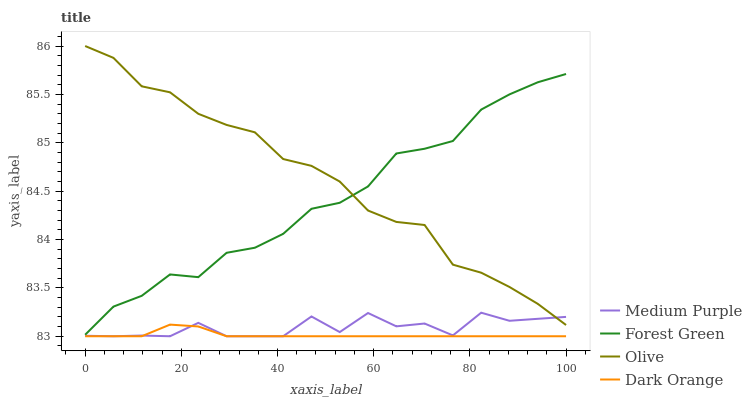Does Dark Orange have the minimum area under the curve?
Answer yes or no. Yes. Does Olive have the maximum area under the curve?
Answer yes or no. Yes. Does Forest Green have the minimum area under the curve?
Answer yes or no. No. Does Forest Green have the maximum area under the curve?
Answer yes or no. No. Is Dark Orange the smoothest?
Answer yes or no. Yes. Is Medium Purple the roughest?
Answer yes or no. Yes. Is Olive the smoothest?
Answer yes or no. No. Is Olive the roughest?
Answer yes or no. No. Does Medium Purple have the lowest value?
Answer yes or no. Yes. Does Forest Green have the lowest value?
Answer yes or no. No. Does Olive have the highest value?
Answer yes or no. Yes. Does Forest Green have the highest value?
Answer yes or no. No. Is Dark Orange less than Forest Green?
Answer yes or no. Yes. Is Olive greater than Dark Orange?
Answer yes or no. Yes. Does Medium Purple intersect Dark Orange?
Answer yes or no. Yes. Is Medium Purple less than Dark Orange?
Answer yes or no. No. Is Medium Purple greater than Dark Orange?
Answer yes or no. No. Does Dark Orange intersect Forest Green?
Answer yes or no. No. 